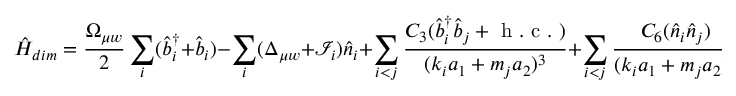Convert formula to latex. <formula><loc_0><loc_0><loc_500><loc_500>\hat { H } _ { d i m } = \frac { \Omega _ { \mu w } } { 2 } \sum _ { i } ( \hat { b } _ { i } ^ { \dagger } + \hat { b } _ { i } ) - \sum _ { i } ( \Delta _ { \mu w } + \mathcal { I } _ { i } ) \hat { n } _ { i } + \sum _ { i < j } \frac { C _ { 3 } ( \hat { b } _ { i } ^ { \dagger } \hat { b } _ { j } + h . c . ) } { ( k _ { i } a _ { 1 } + m _ { j } a _ { 2 } ) ^ { 3 } } + \sum _ { i < j } \frac { C _ { 6 } ( \hat { n } _ { i } \hat { n } _ { j } ) } { ( k _ { i } a _ { 1 } + m _ { j } a _ { 2 } ) ^ { 6 } } ,</formula> 